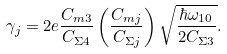Convert formula to latex. <formula><loc_0><loc_0><loc_500><loc_500>\gamma _ { j } = 2 e \frac { C _ { m 3 } } { C _ { \Sigma 4 } } \left ( \frac { C _ { m j } } { C _ { \Sigma j } } \right ) \sqrt { \frac { \hbar { \omega } _ { 1 0 } } { 2 C _ { \Sigma 3 } } } .</formula> 